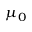<formula> <loc_0><loc_0><loc_500><loc_500>\mu _ { 0 }</formula> 